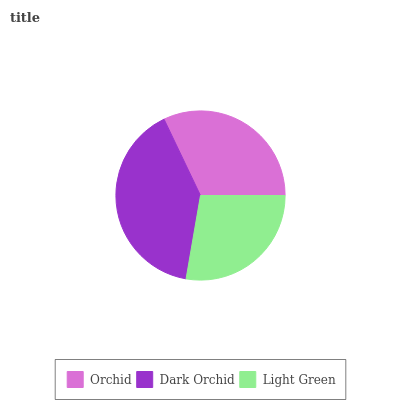Is Light Green the minimum?
Answer yes or no. Yes. Is Dark Orchid the maximum?
Answer yes or no. Yes. Is Dark Orchid the minimum?
Answer yes or no. No. Is Light Green the maximum?
Answer yes or no. No. Is Dark Orchid greater than Light Green?
Answer yes or no. Yes. Is Light Green less than Dark Orchid?
Answer yes or no. Yes. Is Light Green greater than Dark Orchid?
Answer yes or no. No. Is Dark Orchid less than Light Green?
Answer yes or no. No. Is Orchid the high median?
Answer yes or no. Yes. Is Orchid the low median?
Answer yes or no. Yes. Is Light Green the high median?
Answer yes or no. No. Is Light Green the low median?
Answer yes or no. No. 